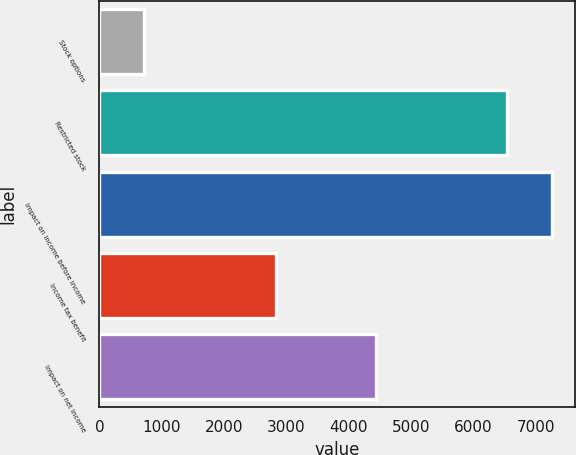<chart> <loc_0><loc_0><loc_500><loc_500><bar_chart><fcel>Stock options<fcel>Restricted stock<fcel>Impact on income before income<fcel>Income tax benefit<fcel>Impact on net income<nl><fcel>720<fcel>6541<fcel>7261<fcel>2827<fcel>4434<nl></chart> 